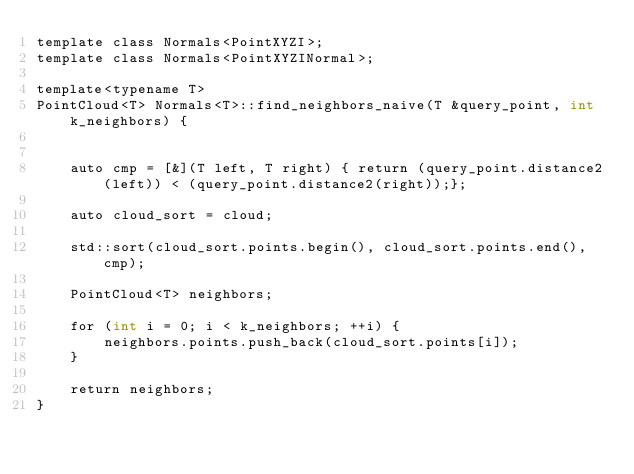Convert code to text. <code><loc_0><loc_0><loc_500><loc_500><_Cuda_>template class Normals<PointXYZI>;
template class Normals<PointXYZINormal>;

template<typename T>
PointCloud<T> Normals<T>::find_neighbors_naive(T &query_point, int k_neighbors) {


    auto cmp = [&](T left, T right) { return (query_point.distance2(left)) < (query_point.distance2(right));};

    auto cloud_sort = cloud;

    std::sort(cloud_sort.points.begin(), cloud_sort.points.end(), cmp);

    PointCloud<T> neighbors;

    for (int i = 0; i < k_neighbors; ++i) {
        neighbors.points.push_back(cloud_sort.points[i]);
    }

    return neighbors;
}
</code> 